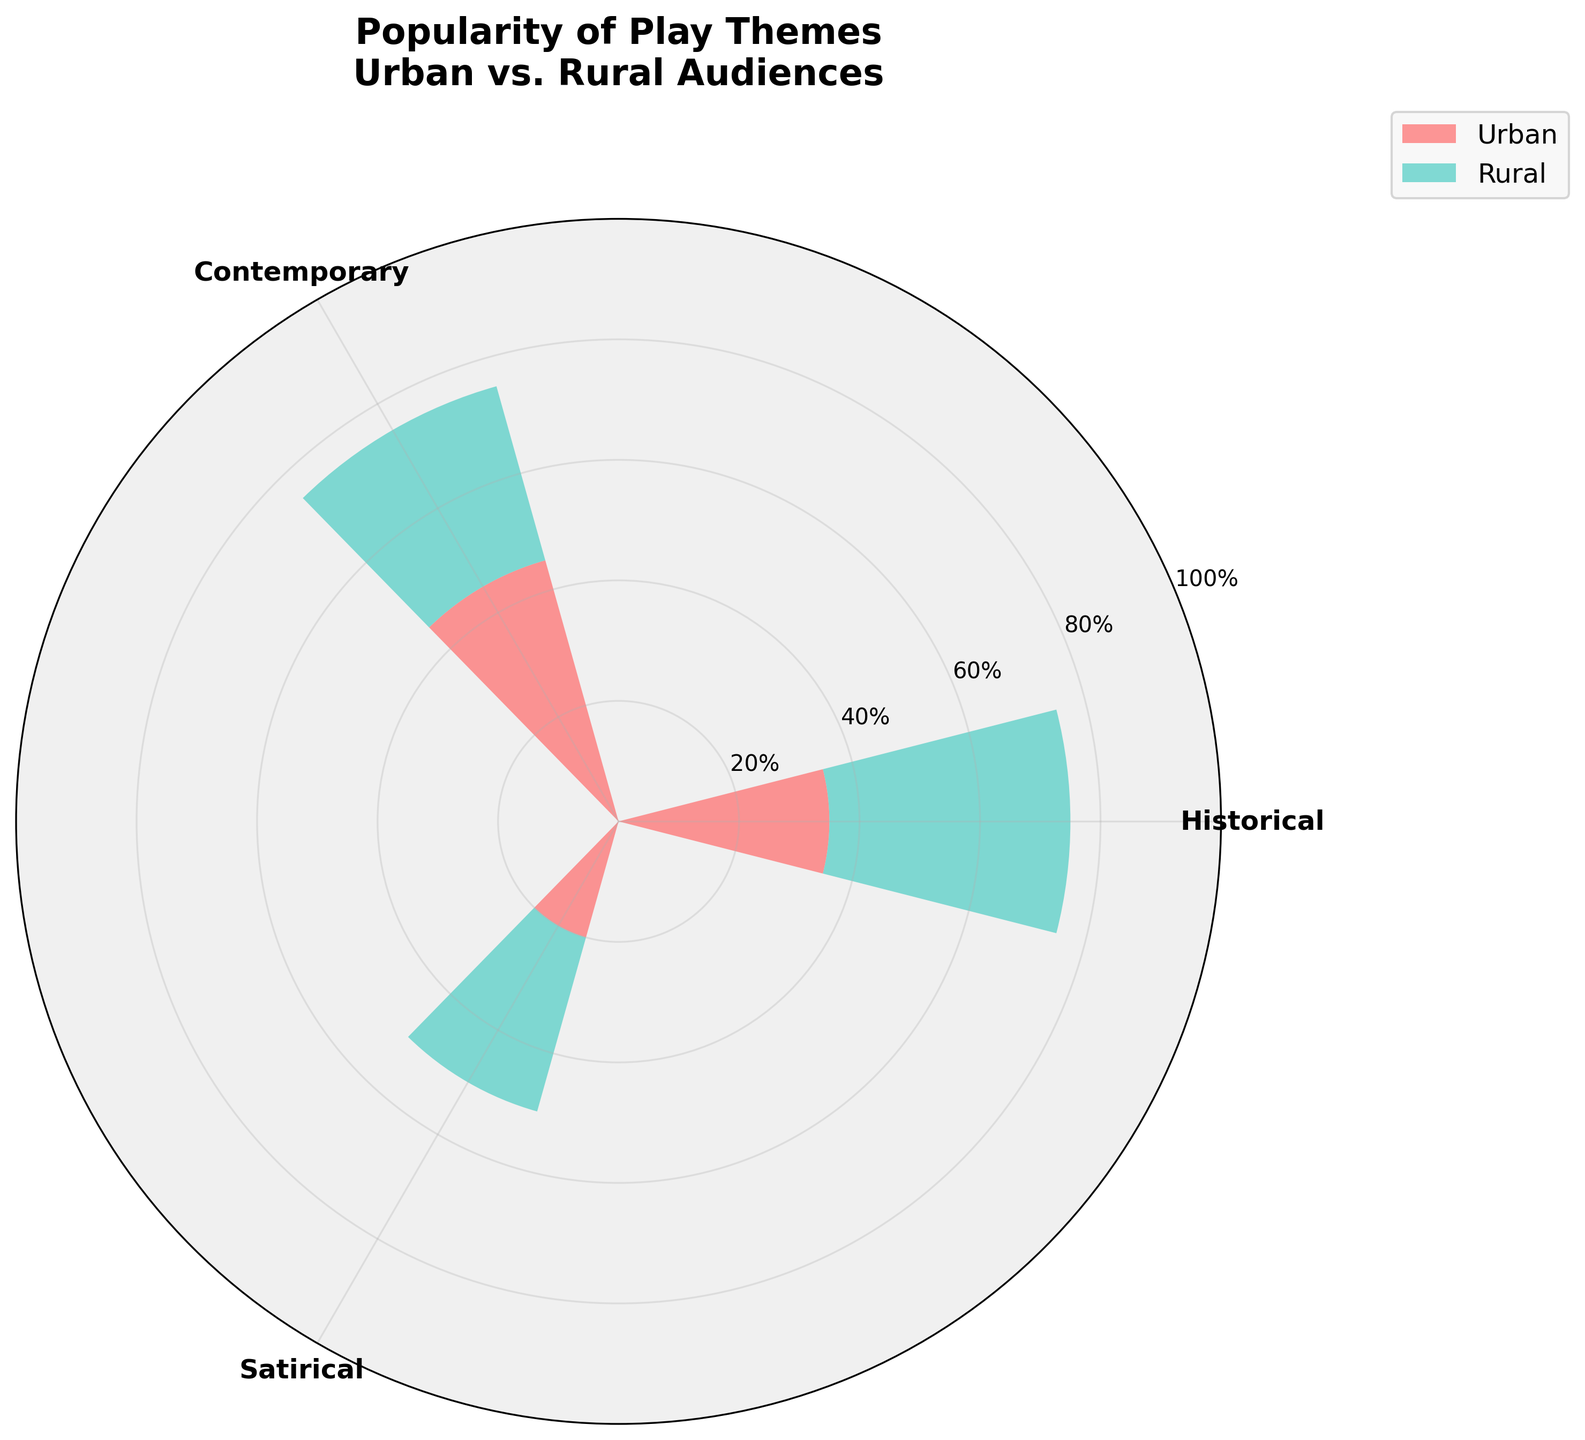What are the different themes included in the plot? The plot includes three themes: Historical, Contemporary, and Satirical. These can be identified from the labels on the radial axes of the rose chart.
Answer: Historical, Contemporary, Satirical What is the title of the plot? The title of the plot is "Popularity of Play Themes\nUrban vs. Rural Audiences". This information is clearly displayed at the top of the chart.
Answer: Popularity of Play Themes\nUrban vs. Rural Audiences Which audience group shows higher popularity for Historical themes? By comparing the segment lengths on the rose chart, we find that the Rural audience shows higher popularity with a combined segment length of 40, whereas the Urban audience has a segment length of 35.
Answer: Rural What is the total popularity percentage for Satirical themes among Urban and Rural audiences combined? The Urban audience has a popularity percentage of 20, and the Rural audience has 30 for Satirical themes. Therefore, the total is 20 + 30 = 50.
Answer: 50 Which theme has the least popularity among Urban audiences? By comparing the lengths of the Urban segments on the chart, we see that Satirical themes have the shortest segment length of 20, making it the least popular among Urban audiences.
Answer: Satirical By how much percent is Contemporary theme more popular among Urban audiences compared to Rural audiences? The Contemporary theme has a popularity percentage of 45 among Urban audiences and 30 among Rural audiences. The difference is 45 - 30 = 15%.
Answer: 15% Which theme has the closest popularity percentages between Urban and Rural audiences? Historical themes have popularity percentages of 35 (Urban) and 40 (Rural), resulting in a difference of only 5%, which is the smallest difference among the three themes.
Answer: Historical What is the average popularity percentage of Historical themes across both Urban and Rural audiences? The Historical themes have popularity percentages of 35 (Urban) and 40 (Rural). The average is calculated as (35 + 40) / 2 = 37.5.
Answer: 37.5 Which theme is the most popular among Urban audiences? The theme with the longest Urban segment on the chart is Contemporary, with a popularity percentage of 45.
Answer: Contemporary 